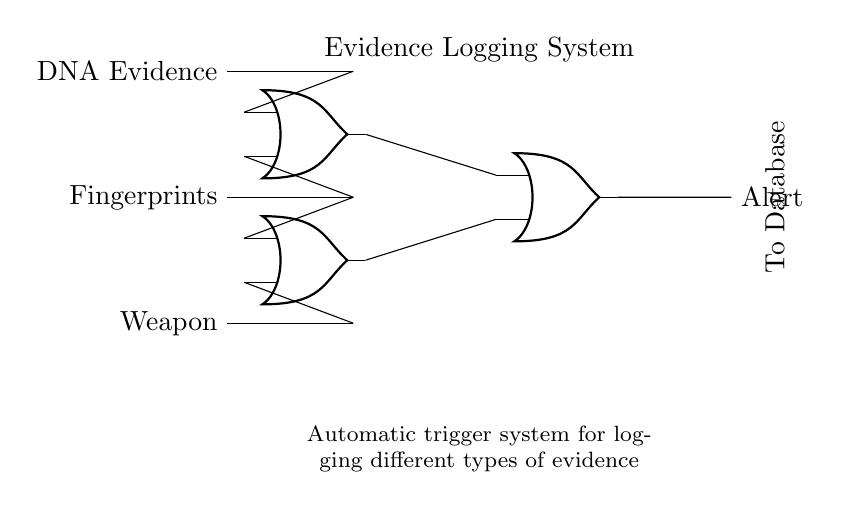What types of evidence are connected to the system? The diagram shows three types of evidence: DNA Evidence, Fingerprints, and Weapon. These are listed as inputs to the system where each type connects to the inputs of the OR gates.
Answer: DNA Evidence, Fingerprints, Weapon How many OR gates are there in the circuit? The circuit contains three OR gates. This is determined by counting the symbols labeled as OR gates in the diagram.
Answer: three What does the output signal indicate? The output signal labeled "Alert" indicates that the automatic evidence logging system is triggered and has detected evidence that requires logging. This conclusion is drawn from the final node in the circuit connected to the outputs of the OR gates.
Answer: Alert Which OR gate receives DNA Evidence? DNA Evidence is connected to the first OR gate, as indicated by the line from the input labeled "DNA Evidence" leading to the input of that gate in the diagram.
Answer: first OR gate Which types of evidence trigger the final alert? The final alert is triggered by the combinations of the first and second OR gates in the circuit, meaning if DNA Evidence, Fingerprints, or Weapon is detected, an alert will be generated. The outputs from the OR gates are connected to the final alert output.
Answer: DNA Evidence, Fingerprints, Weapon What is the purpose of the connections between OR gates and the output? The connections between the OR gates and the output serve to combine the logical conditions from both OR gates to determine if an alert should be triggered, reflecting that at least one type of evidence must be present to activate the alert. This is an application of the OR logic function.
Answer: To combine conditions for alert 